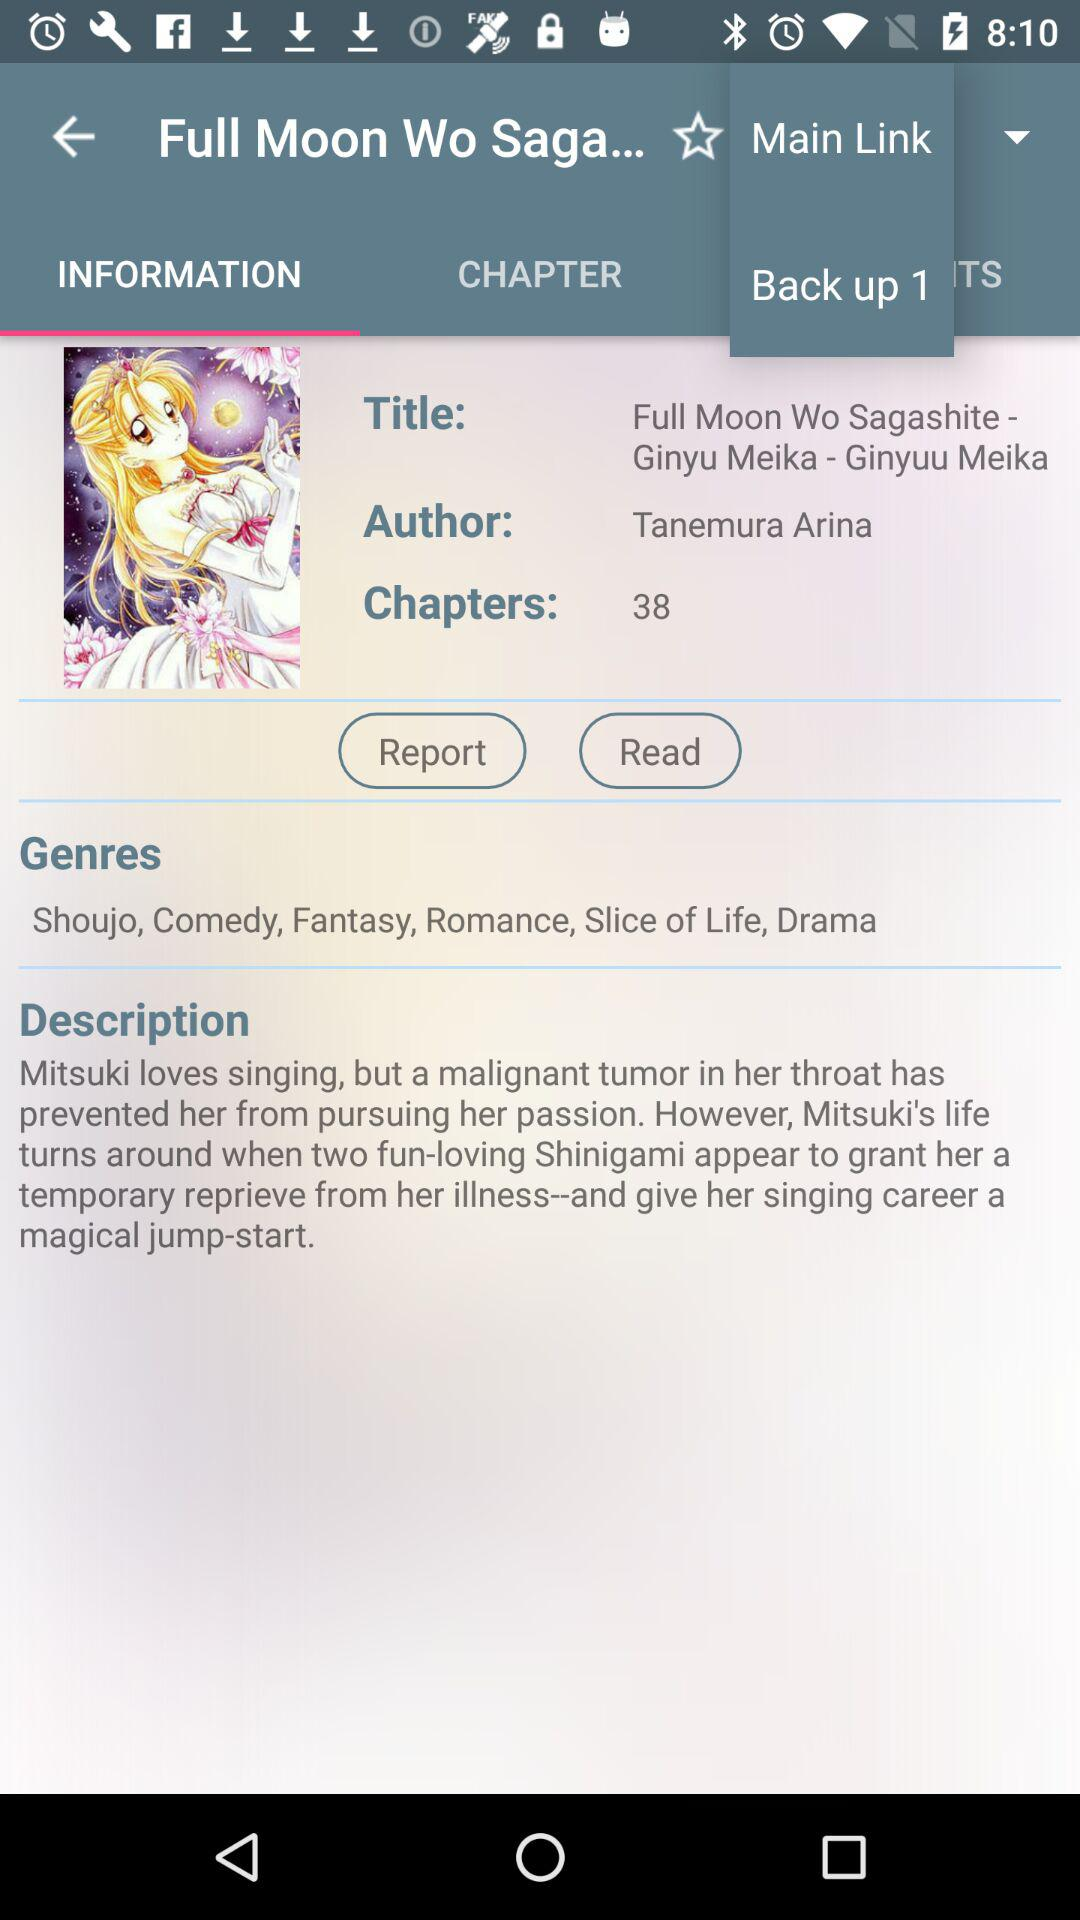Which tab is selected? The selected tab is "INFORMATION". 